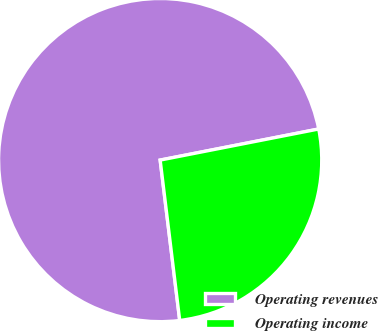<chart> <loc_0><loc_0><loc_500><loc_500><pie_chart><fcel>Operating revenues<fcel>Operating income<nl><fcel>73.85%<fcel>26.15%<nl></chart> 